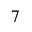Convert formula to latex. <formula><loc_0><loc_0><loc_500><loc_500>7</formula> 